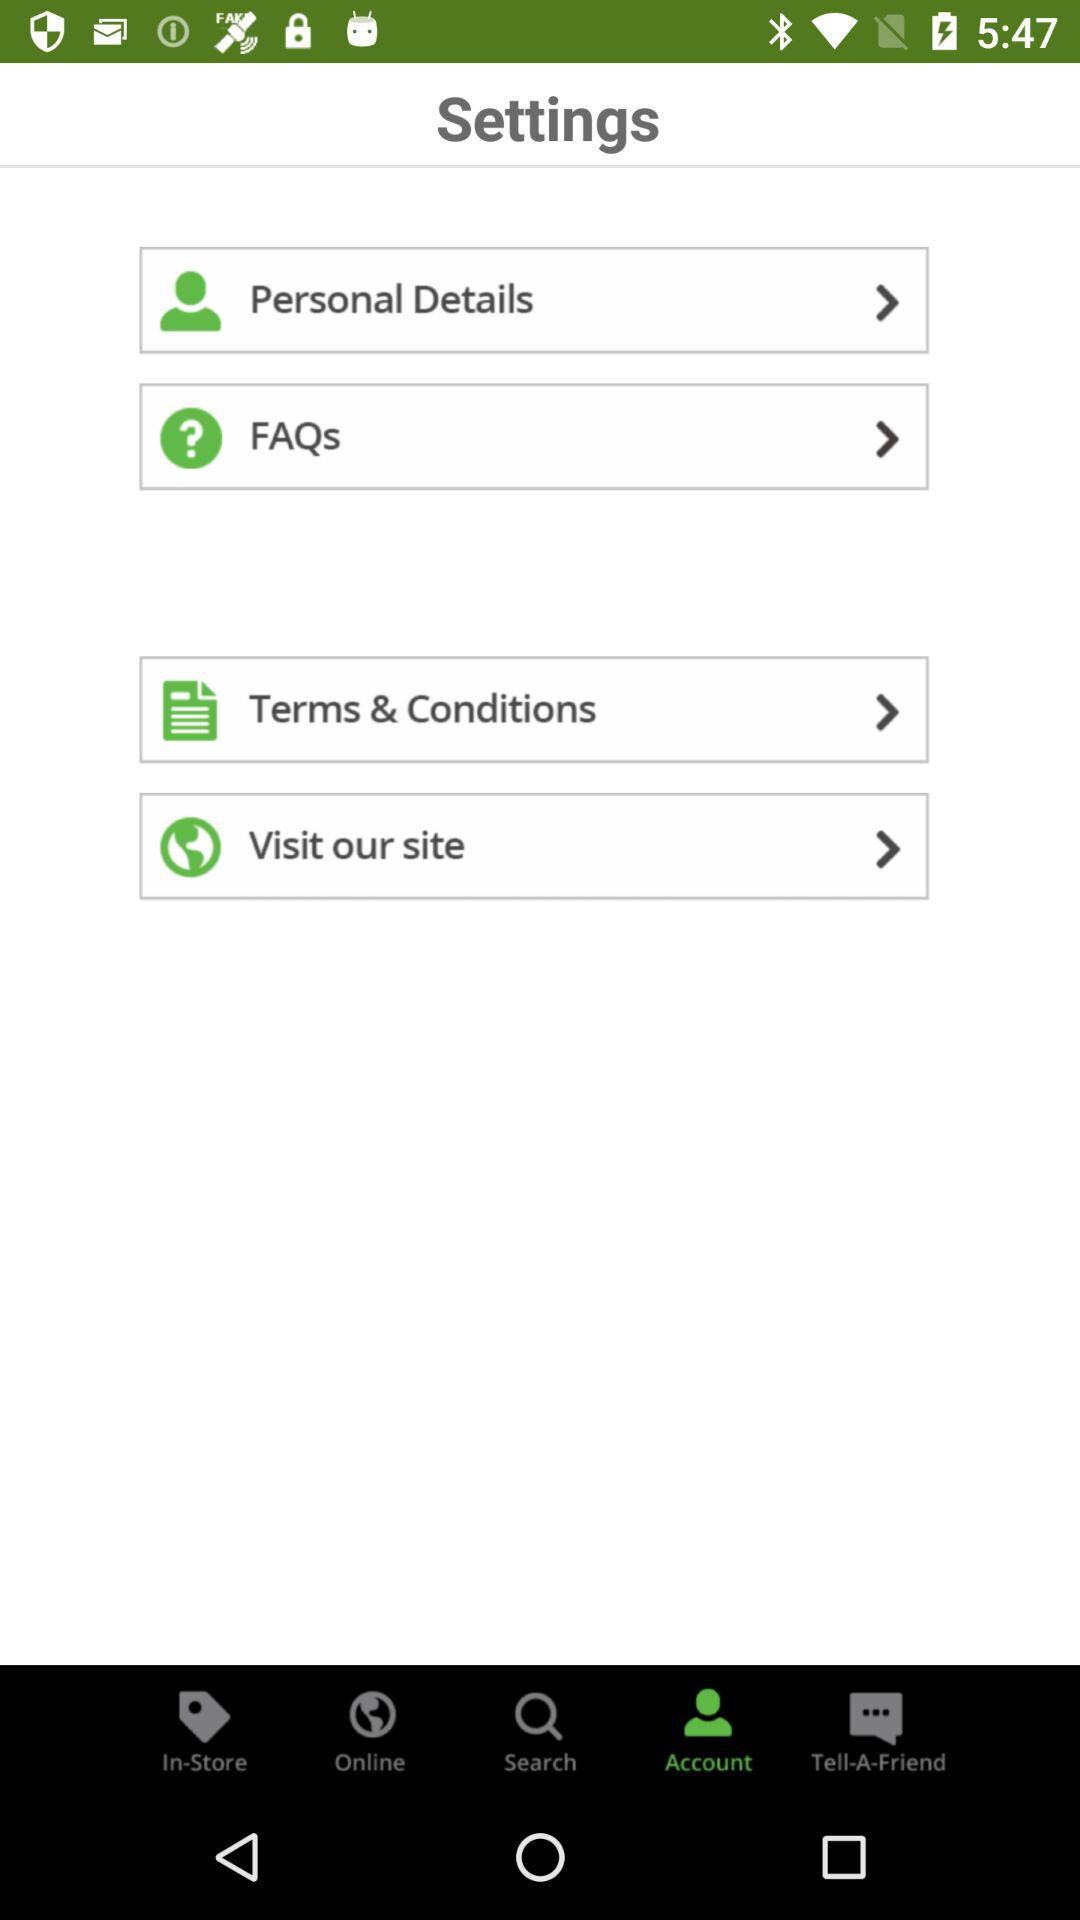Which tab is selected? The selected tab is "Account". 